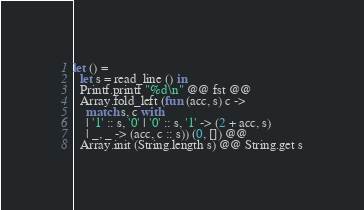Convert code to text. <code><loc_0><loc_0><loc_500><loc_500><_OCaml_>let () =
  let s = read_line () in
  Printf.printf "%d\n" @@ fst @@ 
  Array.fold_left (fun (acc, s) c ->
    match s, c with
    | '1' :: s, '0' | '0' :: s, '1' -> (2 + acc, s)
    | _, _ -> (acc, c :: s)) (0, []) @@
  Array.init (String.length s) @@ String.get s

</code> 